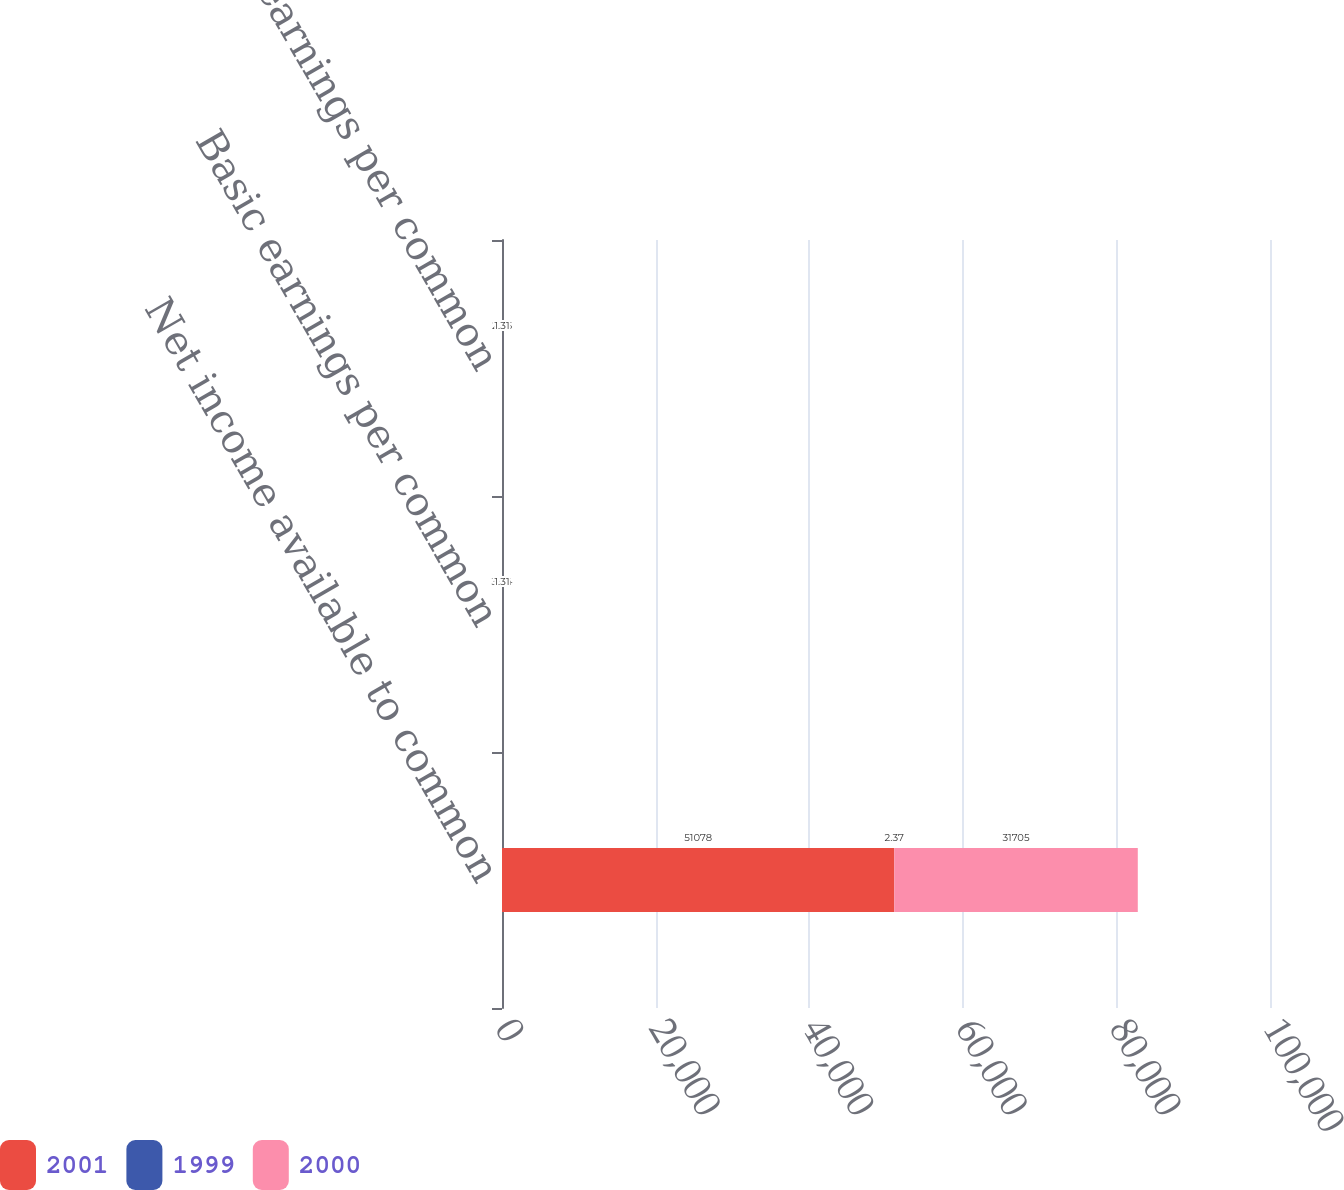<chart> <loc_0><loc_0><loc_500><loc_500><stacked_bar_chart><ecel><fcel>Net income available to common<fcel>Basic earnings per common<fcel>Diluted earnings per common<nl><fcel>2001<fcel>51078<fcel>1.89<fcel>1.87<nl><fcel>1999<fcel>2.37<fcel>3.04<fcel>2.85<nl><fcel>2000<fcel>31705<fcel>1.31<fcel>1.31<nl></chart> 